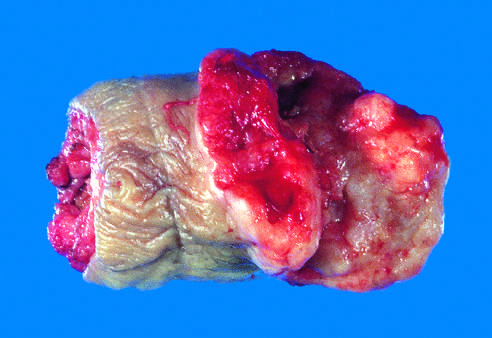s the glans penis deformed by an ulcerated, infiltrative mass?
Answer the question using a single word or phrase. Yes 